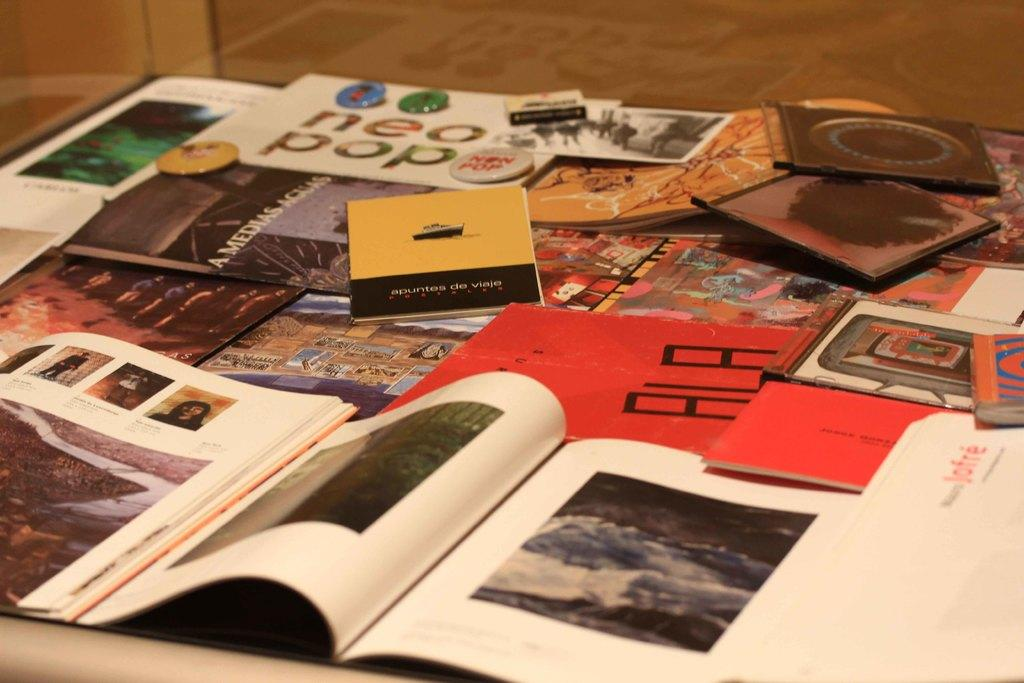<image>
Describe the image concisely. Open book next to some other books including one titled "Neopop". 